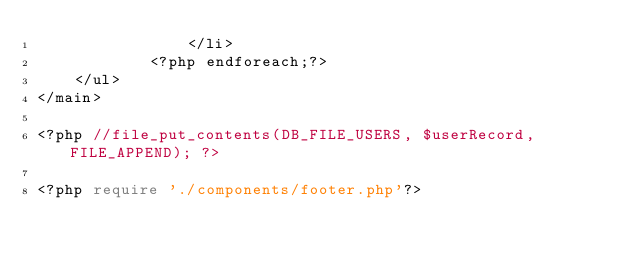Convert code to text. <code><loc_0><loc_0><loc_500><loc_500><_PHP_>	            </li>
	        <?php endforeach;?>
    </ul>
</main>

<?php //file_put_contents(DB_FILE_USERS, $userRecord, FILE_APPEND); ?>

<?php require './components/footer.php'?></code> 